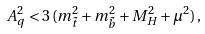Convert formula to latex. <formula><loc_0><loc_0><loc_500><loc_500>A _ { q } ^ { 2 } < 3 \, ( m _ { \tilde { t } } ^ { 2 } + m _ { \tilde { b } } ^ { 2 } + M _ { H } ^ { 2 } + \mu ^ { 2 } ) \, ,</formula> 